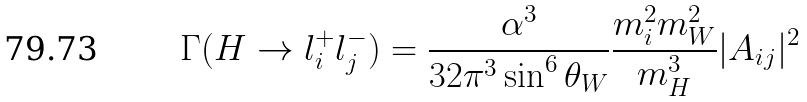Convert formula to latex. <formula><loc_0><loc_0><loc_500><loc_500>\Gamma ( H \to l ^ { + } _ { i } l ^ { - } _ { j } ) = \frac { \alpha ^ { 3 } } { 3 2 \pi ^ { 3 } \sin ^ { 6 } \theta _ { W } } \frac { m ^ { 2 } _ { i } m ^ { 2 } _ { W } } { m ^ { 3 } _ { H } } | A _ { i j } | ^ { 2 }</formula> 